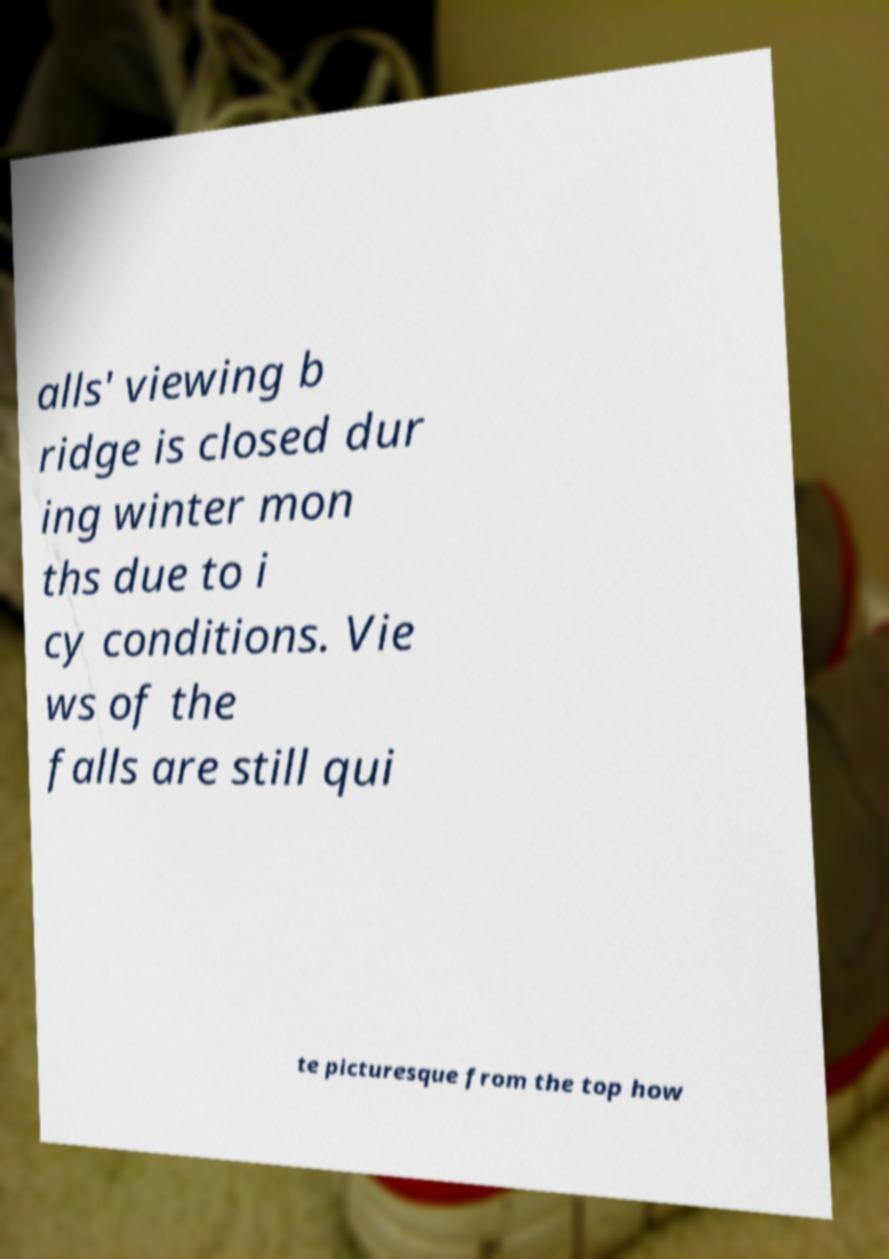There's text embedded in this image that I need extracted. Can you transcribe it verbatim? alls' viewing b ridge is closed dur ing winter mon ths due to i cy conditions. Vie ws of the falls are still qui te picturesque from the top how 